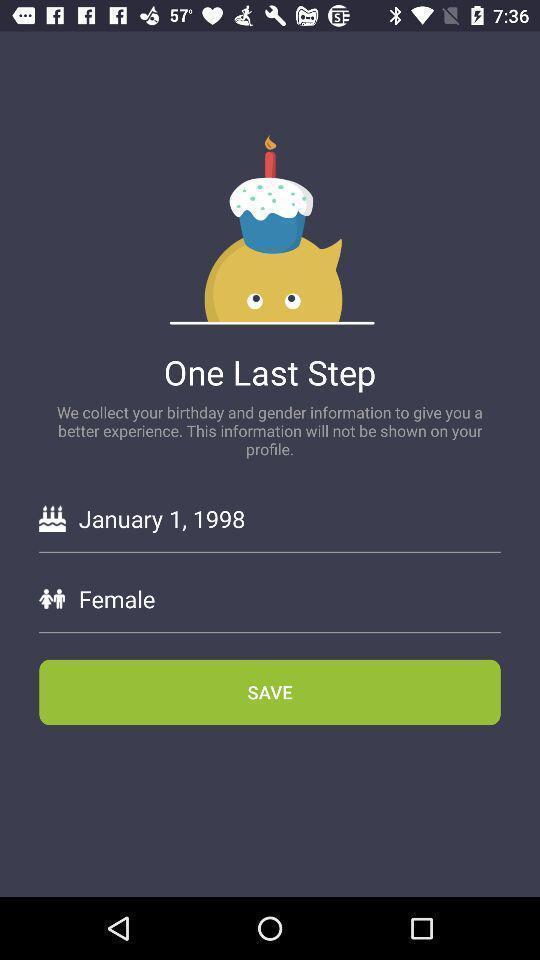Give me a narrative description of this picture. Sign up page. 